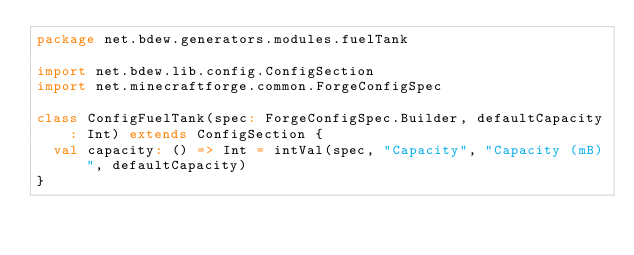<code> <loc_0><loc_0><loc_500><loc_500><_Scala_>package net.bdew.generators.modules.fuelTank

import net.bdew.lib.config.ConfigSection
import net.minecraftforge.common.ForgeConfigSpec

class ConfigFuelTank(spec: ForgeConfigSpec.Builder, defaultCapacity: Int) extends ConfigSection {
  val capacity: () => Int = intVal(spec, "Capacity", "Capacity (mB)", defaultCapacity)
}
</code> 